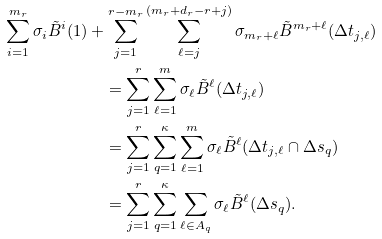<formula> <loc_0><loc_0><loc_500><loc_500>\sum _ { i = 1 } ^ { m _ { r } } \sigma _ { i } \tilde { B } ^ { i } ( 1 ) & + \sum _ { j = 1 } ^ { r - m _ { r } } \sum _ { \ell = j } ^ { ( m _ { r } + d _ { r } - r + j ) } \sigma _ { m _ { r } + \ell } \tilde { B } ^ { m _ { r } + \ell } ( \Delta t _ { j , \ell } ) \\ & \quad = \sum _ { j = 1 } ^ { r } \sum _ { \ell = 1 } ^ { m } \sigma _ { \ell } \tilde { B } ^ { \ell } ( \Delta t _ { j , \ell } ) \\ & \quad = \sum _ { j = 1 } ^ { r } \sum _ { q = 1 } ^ { \kappa } \sum _ { \ell = 1 } ^ { m } \sigma _ { \ell } \tilde { B } ^ { \ell } ( \Delta t _ { j , \ell } \cap \Delta s _ { q } ) \\ & \quad = \sum _ { j = 1 } ^ { r } \sum _ { q = 1 } ^ { \kappa } \sum _ { \ell \in A _ { q } } \sigma _ { \ell } \tilde { B } ^ { \ell } ( \Delta s _ { q } ) .</formula> 